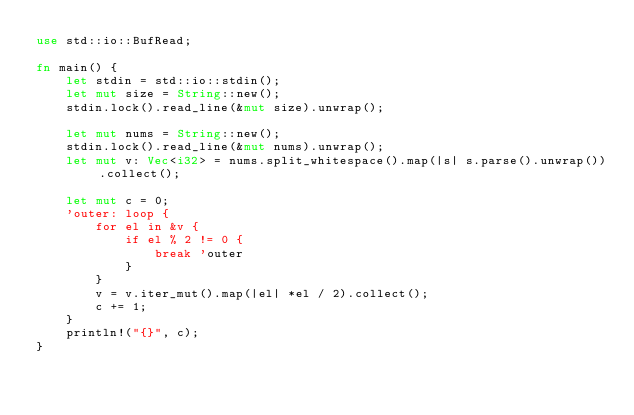Convert code to text. <code><loc_0><loc_0><loc_500><loc_500><_Rust_>use std::io::BufRead;

fn main() {
    let stdin = std::io::stdin();
    let mut size = String::new();
    stdin.lock().read_line(&mut size).unwrap();

    let mut nums = String::new();
    stdin.lock().read_line(&mut nums).unwrap();
    let mut v: Vec<i32> = nums.split_whitespace().map(|s| s.parse().unwrap()).collect();

    let mut c = 0;
    'outer: loop {
        for el in &v {
            if el % 2 != 0 {
                break 'outer
            }
        }
        v = v.iter_mut().map(|el| *el / 2).collect();
        c += 1;
    }
    println!("{}", c);
}</code> 